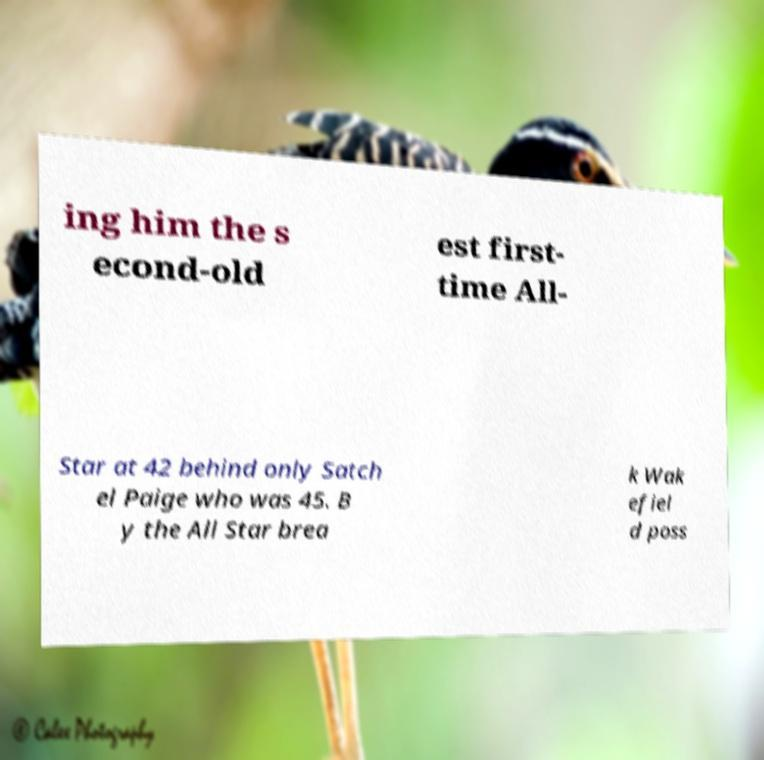Can you read and provide the text displayed in the image?This photo seems to have some interesting text. Can you extract and type it out for me? ing him the s econd-old est first- time All- Star at 42 behind only Satch el Paige who was 45. B y the All Star brea k Wak efiel d poss 